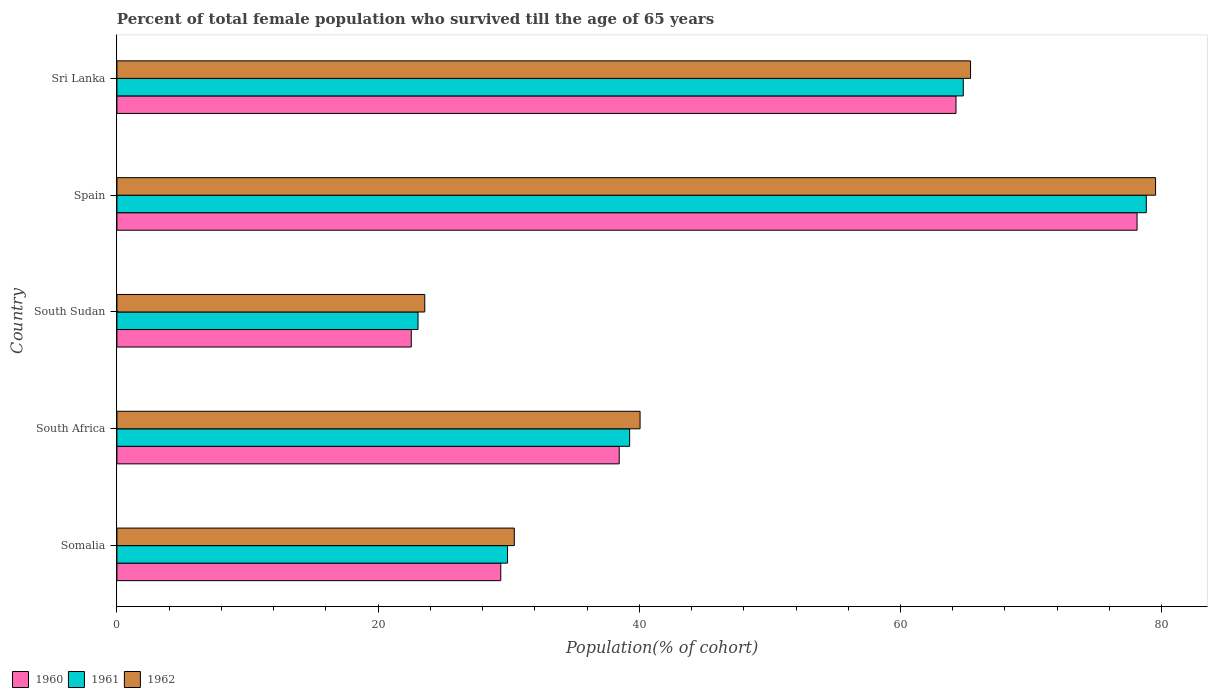How many different coloured bars are there?
Your answer should be compact. 3. How many groups of bars are there?
Provide a short and direct response. 5. Are the number of bars per tick equal to the number of legend labels?
Your answer should be very brief. Yes. Are the number of bars on each tick of the Y-axis equal?
Offer a very short reply. Yes. How many bars are there on the 4th tick from the top?
Your answer should be very brief. 3. How many bars are there on the 5th tick from the bottom?
Give a very brief answer. 3. What is the label of the 3rd group of bars from the top?
Keep it short and to the point. South Sudan. In how many cases, is the number of bars for a given country not equal to the number of legend labels?
Offer a very short reply. 0. What is the percentage of total female population who survived till the age of 65 years in 1962 in Spain?
Your response must be concise. 79.53. Across all countries, what is the maximum percentage of total female population who survived till the age of 65 years in 1960?
Ensure brevity in your answer.  78.12. Across all countries, what is the minimum percentage of total female population who survived till the age of 65 years in 1961?
Give a very brief answer. 23.06. In which country was the percentage of total female population who survived till the age of 65 years in 1962 minimum?
Your answer should be compact. South Sudan. What is the total percentage of total female population who survived till the age of 65 years in 1962 in the graph?
Provide a succinct answer. 238.96. What is the difference between the percentage of total female population who survived till the age of 65 years in 1961 in Somalia and that in Spain?
Give a very brief answer. -48.91. What is the difference between the percentage of total female population who survived till the age of 65 years in 1962 in Somalia and the percentage of total female population who survived till the age of 65 years in 1960 in South Sudan?
Give a very brief answer. 7.89. What is the average percentage of total female population who survived till the age of 65 years in 1962 per country?
Keep it short and to the point. 47.79. What is the difference between the percentage of total female population who survived till the age of 65 years in 1961 and percentage of total female population who survived till the age of 65 years in 1962 in Somalia?
Provide a succinct answer. -0.52. In how many countries, is the percentage of total female population who survived till the age of 65 years in 1962 greater than 68 %?
Your response must be concise. 1. What is the ratio of the percentage of total female population who survived till the age of 65 years in 1961 in South Africa to that in Spain?
Keep it short and to the point. 0.5. Is the difference between the percentage of total female population who survived till the age of 65 years in 1961 in Spain and Sri Lanka greater than the difference between the percentage of total female population who survived till the age of 65 years in 1962 in Spain and Sri Lanka?
Your answer should be very brief. No. What is the difference between the highest and the second highest percentage of total female population who survived till the age of 65 years in 1960?
Your answer should be compact. 13.86. What is the difference between the highest and the lowest percentage of total female population who survived till the age of 65 years in 1960?
Offer a very short reply. 55.58. In how many countries, is the percentage of total female population who survived till the age of 65 years in 1961 greater than the average percentage of total female population who survived till the age of 65 years in 1961 taken over all countries?
Your response must be concise. 2. Is the sum of the percentage of total female population who survived till the age of 65 years in 1961 in Somalia and South Sudan greater than the maximum percentage of total female population who survived till the age of 65 years in 1962 across all countries?
Ensure brevity in your answer.  No. What does the 2nd bar from the top in Somalia represents?
Your answer should be compact. 1961. Is it the case that in every country, the sum of the percentage of total female population who survived till the age of 65 years in 1961 and percentage of total female population who survived till the age of 65 years in 1960 is greater than the percentage of total female population who survived till the age of 65 years in 1962?
Offer a very short reply. Yes. How many bars are there?
Keep it short and to the point. 15. How many countries are there in the graph?
Keep it short and to the point. 5. Does the graph contain any zero values?
Provide a short and direct response. No. Does the graph contain grids?
Your answer should be compact. No. How are the legend labels stacked?
Offer a very short reply. Horizontal. What is the title of the graph?
Provide a short and direct response. Percent of total female population who survived till the age of 65 years. Does "2009" appear as one of the legend labels in the graph?
Offer a terse response. No. What is the label or title of the X-axis?
Make the answer very short. Population(% of cohort). What is the Population(% of cohort) of 1960 in Somalia?
Give a very brief answer. 29.39. What is the Population(% of cohort) in 1961 in Somalia?
Your response must be concise. 29.91. What is the Population(% of cohort) of 1962 in Somalia?
Your answer should be very brief. 30.43. What is the Population(% of cohort) in 1960 in South Africa?
Your answer should be very brief. 38.46. What is the Population(% of cohort) in 1961 in South Africa?
Ensure brevity in your answer.  39.26. What is the Population(% of cohort) in 1962 in South Africa?
Keep it short and to the point. 40.06. What is the Population(% of cohort) in 1960 in South Sudan?
Make the answer very short. 22.54. What is the Population(% of cohort) of 1961 in South Sudan?
Your response must be concise. 23.06. What is the Population(% of cohort) of 1962 in South Sudan?
Provide a succinct answer. 23.57. What is the Population(% of cohort) in 1960 in Spain?
Your answer should be very brief. 78.12. What is the Population(% of cohort) in 1961 in Spain?
Your response must be concise. 78.83. What is the Population(% of cohort) in 1962 in Spain?
Your response must be concise. 79.53. What is the Population(% of cohort) of 1960 in Sri Lanka?
Your answer should be compact. 64.25. What is the Population(% of cohort) in 1961 in Sri Lanka?
Offer a very short reply. 64.81. What is the Population(% of cohort) in 1962 in Sri Lanka?
Provide a short and direct response. 65.37. Across all countries, what is the maximum Population(% of cohort) in 1960?
Make the answer very short. 78.12. Across all countries, what is the maximum Population(% of cohort) of 1961?
Provide a short and direct response. 78.83. Across all countries, what is the maximum Population(% of cohort) in 1962?
Ensure brevity in your answer.  79.53. Across all countries, what is the minimum Population(% of cohort) in 1960?
Give a very brief answer. 22.54. Across all countries, what is the minimum Population(% of cohort) of 1961?
Make the answer very short. 23.06. Across all countries, what is the minimum Population(% of cohort) in 1962?
Your response must be concise. 23.57. What is the total Population(% of cohort) of 1960 in the graph?
Offer a very short reply. 232.76. What is the total Population(% of cohort) of 1961 in the graph?
Give a very brief answer. 235.86. What is the total Population(% of cohort) in 1962 in the graph?
Offer a terse response. 238.96. What is the difference between the Population(% of cohort) of 1960 in Somalia and that in South Africa?
Make the answer very short. -9.07. What is the difference between the Population(% of cohort) of 1961 in Somalia and that in South Africa?
Offer a terse response. -9.35. What is the difference between the Population(% of cohort) in 1962 in Somalia and that in South Africa?
Your answer should be compact. -9.63. What is the difference between the Population(% of cohort) of 1960 in Somalia and that in South Sudan?
Keep it short and to the point. 6.85. What is the difference between the Population(% of cohort) in 1961 in Somalia and that in South Sudan?
Provide a succinct answer. 6.85. What is the difference between the Population(% of cohort) of 1962 in Somalia and that in South Sudan?
Give a very brief answer. 6.86. What is the difference between the Population(% of cohort) in 1960 in Somalia and that in Spain?
Your response must be concise. -48.72. What is the difference between the Population(% of cohort) in 1961 in Somalia and that in Spain?
Give a very brief answer. -48.91. What is the difference between the Population(% of cohort) in 1962 in Somalia and that in Spain?
Your answer should be very brief. -49.11. What is the difference between the Population(% of cohort) of 1960 in Somalia and that in Sri Lanka?
Your answer should be very brief. -34.86. What is the difference between the Population(% of cohort) of 1961 in Somalia and that in Sri Lanka?
Offer a terse response. -34.9. What is the difference between the Population(% of cohort) in 1962 in Somalia and that in Sri Lanka?
Offer a very short reply. -34.94. What is the difference between the Population(% of cohort) of 1960 in South Africa and that in South Sudan?
Ensure brevity in your answer.  15.92. What is the difference between the Population(% of cohort) in 1961 in South Africa and that in South Sudan?
Keep it short and to the point. 16.2. What is the difference between the Population(% of cohort) of 1962 in South Africa and that in South Sudan?
Offer a terse response. 16.49. What is the difference between the Population(% of cohort) in 1960 in South Africa and that in Spain?
Your response must be concise. -39.65. What is the difference between the Population(% of cohort) in 1961 in South Africa and that in Spain?
Give a very brief answer. -39.56. What is the difference between the Population(% of cohort) in 1962 in South Africa and that in Spain?
Your answer should be compact. -39.47. What is the difference between the Population(% of cohort) in 1960 in South Africa and that in Sri Lanka?
Keep it short and to the point. -25.79. What is the difference between the Population(% of cohort) in 1961 in South Africa and that in Sri Lanka?
Ensure brevity in your answer.  -25.55. What is the difference between the Population(% of cohort) of 1962 in South Africa and that in Sri Lanka?
Offer a terse response. -25.31. What is the difference between the Population(% of cohort) of 1960 in South Sudan and that in Spain?
Your answer should be compact. -55.58. What is the difference between the Population(% of cohort) of 1961 in South Sudan and that in Spain?
Provide a short and direct response. -55.77. What is the difference between the Population(% of cohort) in 1962 in South Sudan and that in Spain?
Offer a very short reply. -55.96. What is the difference between the Population(% of cohort) of 1960 in South Sudan and that in Sri Lanka?
Keep it short and to the point. -41.71. What is the difference between the Population(% of cohort) of 1961 in South Sudan and that in Sri Lanka?
Give a very brief answer. -41.75. What is the difference between the Population(% of cohort) in 1962 in South Sudan and that in Sri Lanka?
Your answer should be very brief. -41.8. What is the difference between the Population(% of cohort) of 1960 in Spain and that in Sri Lanka?
Provide a succinct answer. 13.86. What is the difference between the Population(% of cohort) of 1961 in Spain and that in Sri Lanka?
Provide a short and direct response. 14.02. What is the difference between the Population(% of cohort) of 1962 in Spain and that in Sri Lanka?
Provide a succinct answer. 14.17. What is the difference between the Population(% of cohort) in 1960 in Somalia and the Population(% of cohort) in 1961 in South Africa?
Ensure brevity in your answer.  -9.87. What is the difference between the Population(% of cohort) of 1960 in Somalia and the Population(% of cohort) of 1962 in South Africa?
Your response must be concise. -10.67. What is the difference between the Population(% of cohort) of 1961 in Somalia and the Population(% of cohort) of 1962 in South Africa?
Provide a succinct answer. -10.15. What is the difference between the Population(% of cohort) of 1960 in Somalia and the Population(% of cohort) of 1961 in South Sudan?
Your answer should be compact. 6.34. What is the difference between the Population(% of cohort) of 1960 in Somalia and the Population(% of cohort) of 1962 in South Sudan?
Offer a terse response. 5.82. What is the difference between the Population(% of cohort) in 1961 in Somalia and the Population(% of cohort) in 1962 in South Sudan?
Keep it short and to the point. 6.34. What is the difference between the Population(% of cohort) of 1960 in Somalia and the Population(% of cohort) of 1961 in Spain?
Provide a short and direct response. -49.43. What is the difference between the Population(% of cohort) of 1960 in Somalia and the Population(% of cohort) of 1962 in Spain?
Offer a terse response. -50.14. What is the difference between the Population(% of cohort) of 1961 in Somalia and the Population(% of cohort) of 1962 in Spain?
Provide a succinct answer. -49.62. What is the difference between the Population(% of cohort) of 1960 in Somalia and the Population(% of cohort) of 1961 in Sri Lanka?
Your answer should be compact. -35.42. What is the difference between the Population(% of cohort) in 1960 in Somalia and the Population(% of cohort) in 1962 in Sri Lanka?
Your answer should be very brief. -35.97. What is the difference between the Population(% of cohort) in 1961 in Somalia and the Population(% of cohort) in 1962 in Sri Lanka?
Offer a very short reply. -35.46. What is the difference between the Population(% of cohort) in 1960 in South Africa and the Population(% of cohort) in 1961 in South Sudan?
Your answer should be very brief. 15.41. What is the difference between the Population(% of cohort) in 1960 in South Africa and the Population(% of cohort) in 1962 in South Sudan?
Provide a succinct answer. 14.89. What is the difference between the Population(% of cohort) in 1961 in South Africa and the Population(% of cohort) in 1962 in South Sudan?
Make the answer very short. 15.69. What is the difference between the Population(% of cohort) of 1960 in South Africa and the Population(% of cohort) of 1961 in Spain?
Provide a succinct answer. -40.36. What is the difference between the Population(% of cohort) in 1960 in South Africa and the Population(% of cohort) in 1962 in Spain?
Make the answer very short. -41.07. What is the difference between the Population(% of cohort) in 1961 in South Africa and the Population(% of cohort) in 1962 in Spain?
Provide a short and direct response. -40.27. What is the difference between the Population(% of cohort) of 1960 in South Africa and the Population(% of cohort) of 1961 in Sri Lanka?
Make the answer very short. -26.35. What is the difference between the Population(% of cohort) in 1960 in South Africa and the Population(% of cohort) in 1962 in Sri Lanka?
Provide a short and direct response. -26.9. What is the difference between the Population(% of cohort) in 1961 in South Africa and the Population(% of cohort) in 1962 in Sri Lanka?
Your answer should be very brief. -26.11. What is the difference between the Population(% of cohort) in 1960 in South Sudan and the Population(% of cohort) in 1961 in Spain?
Provide a succinct answer. -56.29. What is the difference between the Population(% of cohort) of 1960 in South Sudan and the Population(% of cohort) of 1962 in Spain?
Your response must be concise. -56.99. What is the difference between the Population(% of cohort) in 1961 in South Sudan and the Population(% of cohort) in 1962 in Spain?
Offer a terse response. -56.48. What is the difference between the Population(% of cohort) in 1960 in South Sudan and the Population(% of cohort) in 1961 in Sri Lanka?
Offer a terse response. -42.27. What is the difference between the Population(% of cohort) of 1960 in South Sudan and the Population(% of cohort) of 1962 in Sri Lanka?
Your answer should be very brief. -42.83. What is the difference between the Population(% of cohort) of 1961 in South Sudan and the Population(% of cohort) of 1962 in Sri Lanka?
Your response must be concise. -42.31. What is the difference between the Population(% of cohort) of 1960 in Spain and the Population(% of cohort) of 1961 in Sri Lanka?
Keep it short and to the point. 13.31. What is the difference between the Population(% of cohort) in 1960 in Spain and the Population(% of cohort) in 1962 in Sri Lanka?
Offer a terse response. 12.75. What is the difference between the Population(% of cohort) of 1961 in Spain and the Population(% of cohort) of 1962 in Sri Lanka?
Make the answer very short. 13.46. What is the average Population(% of cohort) of 1960 per country?
Provide a succinct answer. 46.55. What is the average Population(% of cohort) in 1961 per country?
Make the answer very short. 47.17. What is the average Population(% of cohort) in 1962 per country?
Provide a short and direct response. 47.79. What is the difference between the Population(% of cohort) of 1960 and Population(% of cohort) of 1961 in Somalia?
Your answer should be very brief. -0.52. What is the difference between the Population(% of cohort) in 1960 and Population(% of cohort) in 1962 in Somalia?
Provide a succinct answer. -1.04. What is the difference between the Population(% of cohort) in 1961 and Population(% of cohort) in 1962 in Somalia?
Make the answer very short. -0.52. What is the difference between the Population(% of cohort) in 1960 and Population(% of cohort) in 1961 in South Africa?
Provide a short and direct response. -0.8. What is the difference between the Population(% of cohort) of 1960 and Population(% of cohort) of 1962 in South Africa?
Offer a very short reply. -1.6. What is the difference between the Population(% of cohort) in 1961 and Population(% of cohort) in 1962 in South Africa?
Keep it short and to the point. -0.8. What is the difference between the Population(% of cohort) in 1960 and Population(% of cohort) in 1961 in South Sudan?
Provide a succinct answer. -0.52. What is the difference between the Population(% of cohort) of 1960 and Population(% of cohort) of 1962 in South Sudan?
Offer a terse response. -1.03. What is the difference between the Population(% of cohort) of 1961 and Population(% of cohort) of 1962 in South Sudan?
Ensure brevity in your answer.  -0.52. What is the difference between the Population(% of cohort) of 1960 and Population(% of cohort) of 1961 in Spain?
Ensure brevity in your answer.  -0.71. What is the difference between the Population(% of cohort) in 1960 and Population(% of cohort) in 1962 in Spain?
Keep it short and to the point. -1.42. What is the difference between the Population(% of cohort) of 1961 and Population(% of cohort) of 1962 in Spain?
Your response must be concise. -0.71. What is the difference between the Population(% of cohort) of 1960 and Population(% of cohort) of 1961 in Sri Lanka?
Your response must be concise. -0.56. What is the difference between the Population(% of cohort) in 1960 and Population(% of cohort) in 1962 in Sri Lanka?
Your answer should be very brief. -1.12. What is the difference between the Population(% of cohort) of 1961 and Population(% of cohort) of 1962 in Sri Lanka?
Make the answer very short. -0.56. What is the ratio of the Population(% of cohort) of 1960 in Somalia to that in South Africa?
Give a very brief answer. 0.76. What is the ratio of the Population(% of cohort) of 1961 in Somalia to that in South Africa?
Make the answer very short. 0.76. What is the ratio of the Population(% of cohort) in 1962 in Somalia to that in South Africa?
Your answer should be very brief. 0.76. What is the ratio of the Population(% of cohort) of 1960 in Somalia to that in South Sudan?
Provide a succinct answer. 1.3. What is the ratio of the Population(% of cohort) of 1961 in Somalia to that in South Sudan?
Make the answer very short. 1.3. What is the ratio of the Population(% of cohort) in 1962 in Somalia to that in South Sudan?
Provide a succinct answer. 1.29. What is the ratio of the Population(% of cohort) of 1960 in Somalia to that in Spain?
Offer a terse response. 0.38. What is the ratio of the Population(% of cohort) of 1961 in Somalia to that in Spain?
Keep it short and to the point. 0.38. What is the ratio of the Population(% of cohort) in 1962 in Somalia to that in Spain?
Give a very brief answer. 0.38. What is the ratio of the Population(% of cohort) in 1960 in Somalia to that in Sri Lanka?
Give a very brief answer. 0.46. What is the ratio of the Population(% of cohort) in 1961 in Somalia to that in Sri Lanka?
Provide a succinct answer. 0.46. What is the ratio of the Population(% of cohort) of 1962 in Somalia to that in Sri Lanka?
Offer a terse response. 0.47. What is the ratio of the Population(% of cohort) of 1960 in South Africa to that in South Sudan?
Provide a succinct answer. 1.71. What is the ratio of the Population(% of cohort) in 1961 in South Africa to that in South Sudan?
Your answer should be compact. 1.7. What is the ratio of the Population(% of cohort) of 1962 in South Africa to that in South Sudan?
Ensure brevity in your answer.  1.7. What is the ratio of the Population(% of cohort) in 1960 in South Africa to that in Spain?
Your response must be concise. 0.49. What is the ratio of the Population(% of cohort) in 1961 in South Africa to that in Spain?
Provide a succinct answer. 0.5. What is the ratio of the Population(% of cohort) in 1962 in South Africa to that in Spain?
Your answer should be compact. 0.5. What is the ratio of the Population(% of cohort) in 1960 in South Africa to that in Sri Lanka?
Offer a terse response. 0.6. What is the ratio of the Population(% of cohort) in 1961 in South Africa to that in Sri Lanka?
Provide a succinct answer. 0.61. What is the ratio of the Population(% of cohort) in 1962 in South Africa to that in Sri Lanka?
Keep it short and to the point. 0.61. What is the ratio of the Population(% of cohort) of 1960 in South Sudan to that in Spain?
Keep it short and to the point. 0.29. What is the ratio of the Population(% of cohort) in 1961 in South Sudan to that in Spain?
Your answer should be compact. 0.29. What is the ratio of the Population(% of cohort) of 1962 in South Sudan to that in Spain?
Make the answer very short. 0.3. What is the ratio of the Population(% of cohort) of 1960 in South Sudan to that in Sri Lanka?
Your answer should be compact. 0.35. What is the ratio of the Population(% of cohort) of 1961 in South Sudan to that in Sri Lanka?
Make the answer very short. 0.36. What is the ratio of the Population(% of cohort) in 1962 in South Sudan to that in Sri Lanka?
Provide a succinct answer. 0.36. What is the ratio of the Population(% of cohort) of 1960 in Spain to that in Sri Lanka?
Make the answer very short. 1.22. What is the ratio of the Population(% of cohort) of 1961 in Spain to that in Sri Lanka?
Offer a very short reply. 1.22. What is the ratio of the Population(% of cohort) of 1962 in Spain to that in Sri Lanka?
Your response must be concise. 1.22. What is the difference between the highest and the second highest Population(% of cohort) of 1960?
Give a very brief answer. 13.86. What is the difference between the highest and the second highest Population(% of cohort) in 1961?
Your answer should be compact. 14.02. What is the difference between the highest and the second highest Population(% of cohort) of 1962?
Make the answer very short. 14.17. What is the difference between the highest and the lowest Population(% of cohort) in 1960?
Offer a very short reply. 55.58. What is the difference between the highest and the lowest Population(% of cohort) of 1961?
Provide a succinct answer. 55.77. What is the difference between the highest and the lowest Population(% of cohort) of 1962?
Offer a very short reply. 55.96. 